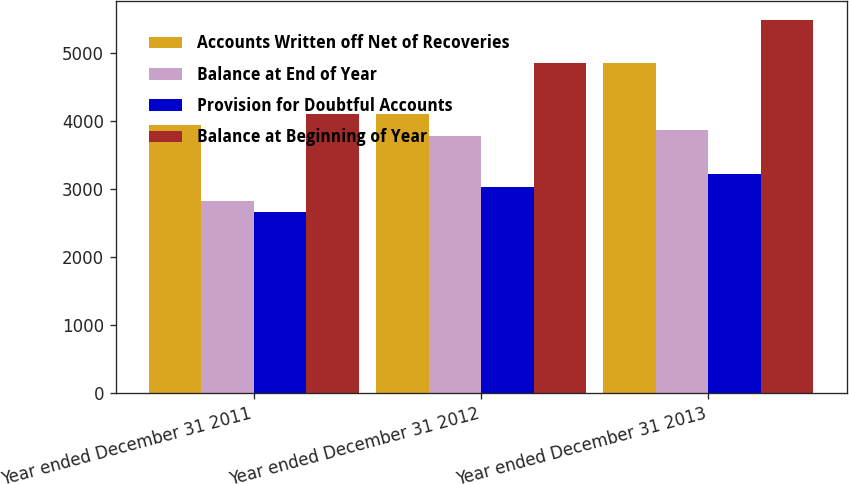<chart> <loc_0><loc_0><loc_500><loc_500><stacked_bar_chart><ecel><fcel>Year ended December 31 2011<fcel>Year ended December 31 2012<fcel>Year ended December 31 2013<nl><fcel>Accounts Written off Net of Recoveries<fcel>3939<fcel>4106<fcel>4846<nl><fcel>Balance at End of Year<fcel>2824<fcel>3770<fcel>3858<nl><fcel>Provision for Doubtful Accounts<fcel>2657<fcel>3030<fcel>3216<nl><fcel>Balance at Beginning of Year<fcel>4106<fcel>4846<fcel>5488<nl></chart> 